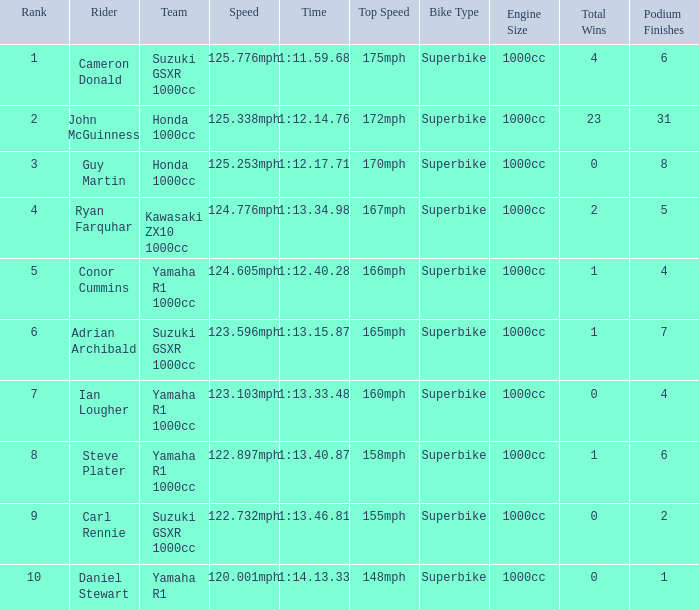What is the rank for the team with a Time of 1:12.40.28? 5.0. Would you be able to parse every entry in this table? {'header': ['Rank', 'Rider', 'Team', 'Speed', 'Time', 'Top Speed', 'Bike Type', 'Engine Size', 'Total Wins', 'Podium Finishes'], 'rows': [['1', 'Cameron Donald', 'Suzuki GSXR 1000cc', '125.776mph', '1:11.59.68', '175mph', 'Superbike', '1000cc', '4', '6'], ['2', 'John McGuinness', 'Honda 1000cc', '125.338mph', '1:12.14.76', '172mph', 'Superbike', '1000cc', '23', '31'], ['3', 'Guy Martin', 'Honda 1000cc', '125.253mph', '1:12.17.71', '170mph', 'Superbike', '1000cc', '0', '8'], ['4', 'Ryan Farquhar', 'Kawasaki ZX10 1000cc', '124.776mph', '1:13.34.98', '167mph', 'Superbike', '1000cc', '2', '5'], ['5', 'Conor Cummins', 'Yamaha R1 1000cc', '124.605mph', '1:12.40.28', '166mph', 'Superbike', '1000cc', '1', '4'], ['6', 'Adrian Archibald', 'Suzuki GSXR 1000cc', '123.596mph', '1:13.15.87', '165mph', 'Superbike', '1000cc', '1', '7'], ['7', 'Ian Lougher', 'Yamaha R1 1000cc', '123.103mph', '1:13.33.48', '160mph', 'Superbike', '1000cc', '0', '4'], ['8', 'Steve Plater', 'Yamaha R1 1000cc', '122.897mph', '1:13.40.87', '158mph', 'Superbike', '1000cc', '1', '6'], ['9', 'Carl Rennie', 'Suzuki GSXR 1000cc', '122.732mph', '1:13.46.81', '155mph', 'Superbike', '1000cc', '0', '2'], ['10', 'Daniel Stewart', 'Yamaha R1', '120.001mph', '1:14.13.33', '148mph', 'Superbike', '1000cc', '0', '1']]} 